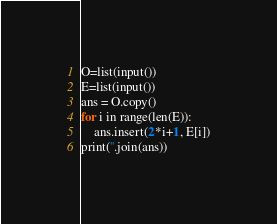<code> <loc_0><loc_0><loc_500><loc_500><_Python_>O=list(input())
E=list(input())
ans = O.copy()
for i in range(len(E)):
    ans.insert(2*i+1, E[i])
print(''.join(ans))</code> 